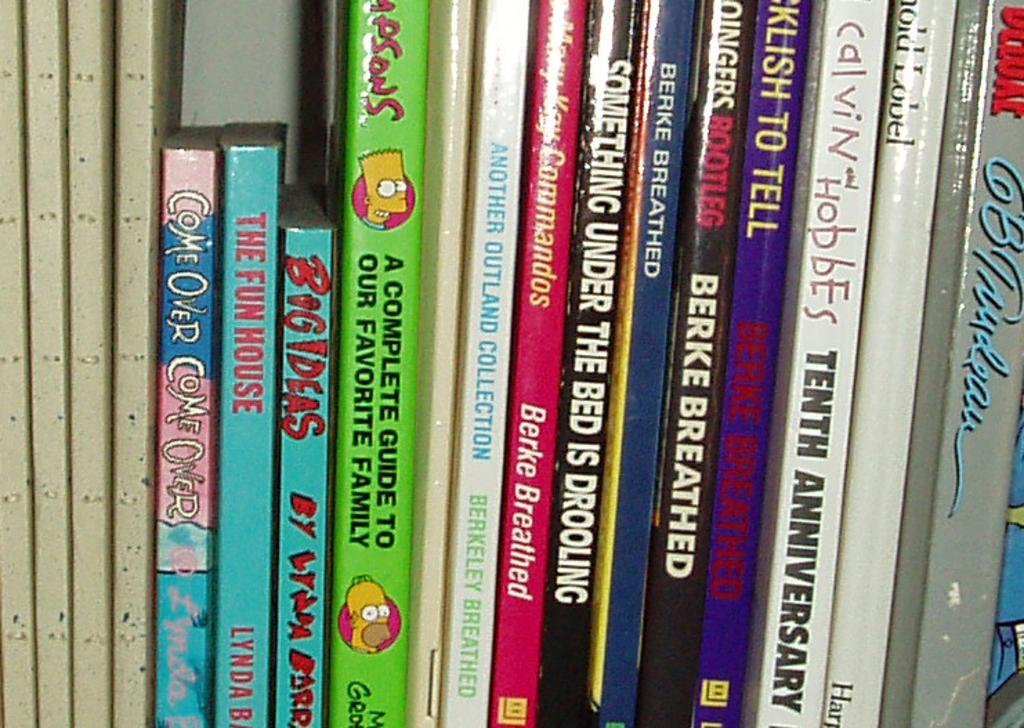<image>
Present a compact description of the photo's key features. Several books stand upright on a shelf, including Calvin and Hobbes, Something Under the Bed Is Drooling, and The Fun House. 